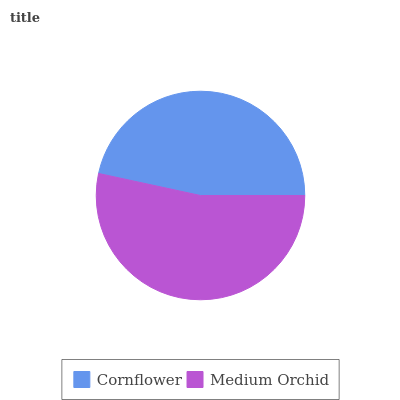Is Cornflower the minimum?
Answer yes or no. Yes. Is Medium Orchid the maximum?
Answer yes or no. Yes. Is Medium Orchid the minimum?
Answer yes or no. No. Is Medium Orchid greater than Cornflower?
Answer yes or no. Yes. Is Cornflower less than Medium Orchid?
Answer yes or no. Yes. Is Cornflower greater than Medium Orchid?
Answer yes or no. No. Is Medium Orchid less than Cornflower?
Answer yes or no. No. Is Medium Orchid the high median?
Answer yes or no. Yes. Is Cornflower the low median?
Answer yes or no. Yes. Is Cornflower the high median?
Answer yes or no. No. Is Medium Orchid the low median?
Answer yes or no. No. 